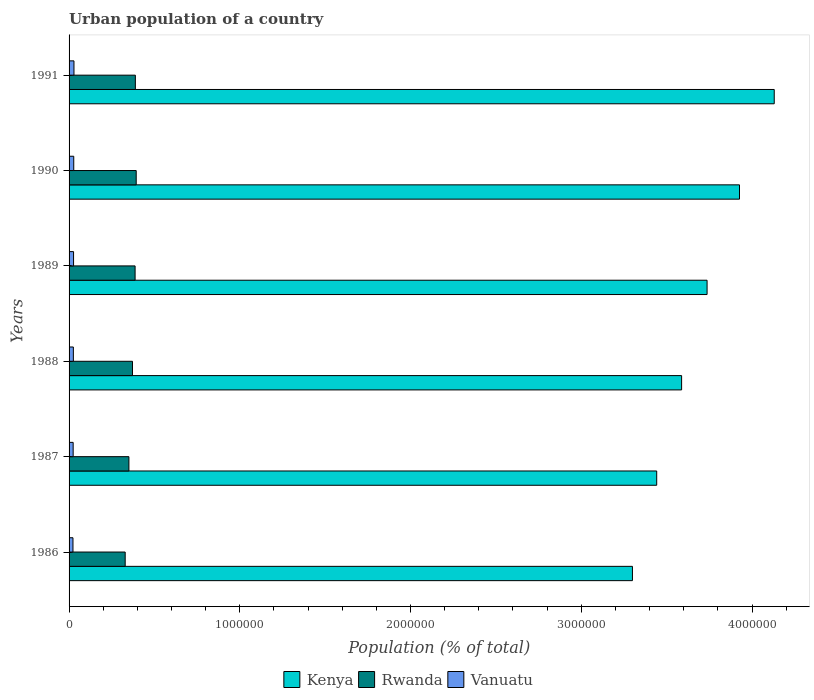How many different coloured bars are there?
Give a very brief answer. 3. How many groups of bars are there?
Offer a very short reply. 6. Are the number of bars per tick equal to the number of legend labels?
Give a very brief answer. Yes. How many bars are there on the 1st tick from the bottom?
Ensure brevity in your answer.  3. What is the urban population in Kenya in 1988?
Your response must be concise. 3.59e+06. Across all years, what is the maximum urban population in Rwanda?
Your response must be concise. 3.93e+05. Across all years, what is the minimum urban population in Kenya?
Offer a terse response. 3.30e+06. In which year was the urban population in Rwanda maximum?
Your answer should be compact. 1990. What is the total urban population in Kenya in the graph?
Keep it short and to the point. 2.21e+07. What is the difference between the urban population in Vanuatu in 1988 and that in 1991?
Your answer should be very brief. -3543. What is the difference between the urban population in Kenya in 1991 and the urban population in Vanuatu in 1988?
Ensure brevity in your answer.  4.11e+06. What is the average urban population in Vanuatu per year?
Provide a succinct answer. 2.57e+04. In the year 1986, what is the difference between the urban population in Rwanda and urban population in Vanuatu?
Give a very brief answer. 3.06e+05. What is the ratio of the urban population in Kenya in 1986 to that in 1991?
Provide a short and direct response. 0.8. Is the urban population in Kenya in 1990 less than that in 1991?
Your answer should be compact. Yes. What is the difference between the highest and the second highest urban population in Kenya?
Your answer should be very brief. 2.03e+05. What is the difference between the highest and the lowest urban population in Kenya?
Offer a terse response. 8.31e+05. What does the 3rd bar from the top in 1987 represents?
Ensure brevity in your answer.  Kenya. What does the 3rd bar from the bottom in 1990 represents?
Provide a succinct answer. Vanuatu. Is it the case that in every year, the sum of the urban population in Kenya and urban population in Vanuatu is greater than the urban population in Rwanda?
Make the answer very short. Yes. How many bars are there?
Your response must be concise. 18. Are all the bars in the graph horizontal?
Keep it short and to the point. Yes. How many years are there in the graph?
Offer a very short reply. 6. Does the graph contain any zero values?
Give a very brief answer. No. Does the graph contain grids?
Ensure brevity in your answer.  No. Where does the legend appear in the graph?
Your response must be concise. Bottom center. How are the legend labels stacked?
Your response must be concise. Horizontal. What is the title of the graph?
Offer a very short reply. Urban population of a country. Does "Chad" appear as one of the legend labels in the graph?
Offer a very short reply. No. What is the label or title of the X-axis?
Ensure brevity in your answer.  Population (% of total). What is the Population (% of total) of Kenya in 1986?
Your response must be concise. 3.30e+06. What is the Population (% of total) in Rwanda in 1986?
Your answer should be very brief. 3.29e+05. What is the Population (% of total) in Vanuatu in 1986?
Keep it short and to the point. 2.28e+04. What is the Population (% of total) in Kenya in 1987?
Your answer should be compact. 3.44e+06. What is the Population (% of total) of Rwanda in 1987?
Offer a very short reply. 3.50e+05. What is the Population (% of total) in Vanuatu in 1987?
Ensure brevity in your answer.  2.39e+04. What is the Population (% of total) of Kenya in 1988?
Provide a short and direct response. 3.59e+06. What is the Population (% of total) in Rwanda in 1988?
Give a very brief answer. 3.71e+05. What is the Population (% of total) in Vanuatu in 1988?
Offer a very short reply. 2.51e+04. What is the Population (% of total) in Kenya in 1989?
Ensure brevity in your answer.  3.74e+06. What is the Population (% of total) of Rwanda in 1989?
Provide a short and direct response. 3.87e+05. What is the Population (% of total) of Vanuatu in 1989?
Ensure brevity in your answer.  2.63e+04. What is the Population (% of total) in Kenya in 1990?
Offer a very short reply. 3.93e+06. What is the Population (% of total) of Rwanda in 1990?
Provide a short and direct response. 3.93e+05. What is the Population (% of total) of Vanuatu in 1990?
Ensure brevity in your answer.  2.74e+04. What is the Population (% of total) in Kenya in 1991?
Your response must be concise. 4.13e+06. What is the Population (% of total) in Rwanda in 1991?
Provide a succinct answer. 3.88e+05. What is the Population (% of total) of Vanuatu in 1991?
Provide a succinct answer. 2.86e+04. Across all years, what is the maximum Population (% of total) in Kenya?
Provide a succinct answer. 4.13e+06. Across all years, what is the maximum Population (% of total) in Rwanda?
Offer a terse response. 3.93e+05. Across all years, what is the maximum Population (% of total) of Vanuatu?
Offer a very short reply. 2.86e+04. Across all years, what is the minimum Population (% of total) of Kenya?
Your response must be concise. 3.30e+06. Across all years, what is the minimum Population (% of total) in Rwanda?
Give a very brief answer. 3.29e+05. Across all years, what is the minimum Population (% of total) in Vanuatu?
Ensure brevity in your answer.  2.28e+04. What is the total Population (% of total) of Kenya in the graph?
Keep it short and to the point. 2.21e+07. What is the total Population (% of total) in Rwanda in the graph?
Offer a very short reply. 2.22e+06. What is the total Population (% of total) in Vanuatu in the graph?
Provide a short and direct response. 1.54e+05. What is the difference between the Population (% of total) of Kenya in 1986 and that in 1987?
Your answer should be very brief. -1.42e+05. What is the difference between the Population (% of total) of Rwanda in 1986 and that in 1987?
Offer a terse response. -2.18e+04. What is the difference between the Population (% of total) in Vanuatu in 1986 and that in 1987?
Offer a very short reply. -1115. What is the difference between the Population (% of total) in Kenya in 1986 and that in 1988?
Make the answer very short. -2.88e+05. What is the difference between the Population (% of total) of Rwanda in 1986 and that in 1988?
Your answer should be very brief. -4.28e+04. What is the difference between the Population (% of total) in Vanuatu in 1986 and that in 1988?
Provide a succinct answer. -2295. What is the difference between the Population (% of total) in Kenya in 1986 and that in 1989?
Provide a short and direct response. -4.37e+05. What is the difference between the Population (% of total) in Rwanda in 1986 and that in 1989?
Your answer should be very brief. -5.80e+04. What is the difference between the Population (% of total) in Vanuatu in 1986 and that in 1989?
Provide a succinct answer. -3528. What is the difference between the Population (% of total) of Kenya in 1986 and that in 1990?
Offer a terse response. -6.27e+05. What is the difference between the Population (% of total) in Rwanda in 1986 and that in 1990?
Offer a very short reply. -6.45e+04. What is the difference between the Population (% of total) in Vanuatu in 1986 and that in 1990?
Offer a very short reply. -4635. What is the difference between the Population (% of total) in Kenya in 1986 and that in 1991?
Provide a short and direct response. -8.31e+05. What is the difference between the Population (% of total) of Rwanda in 1986 and that in 1991?
Provide a succinct answer. -5.96e+04. What is the difference between the Population (% of total) in Vanuatu in 1986 and that in 1991?
Offer a very short reply. -5838. What is the difference between the Population (% of total) in Kenya in 1987 and that in 1988?
Your answer should be compact. -1.46e+05. What is the difference between the Population (% of total) of Rwanda in 1987 and that in 1988?
Make the answer very short. -2.10e+04. What is the difference between the Population (% of total) of Vanuatu in 1987 and that in 1988?
Your response must be concise. -1180. What is the difference between the Population (% of total) of Kenya in 1987 and that in 1989?
Make the answer very short. -2.95e+05. What is the difference between the Population (% of total) of Rwanda in 1987 and that in 1989?
Ensure brevity in your answer.  -3.62e+04. What is the difference between the Population (% of total) of Vanuatu in 1987 and that in 1989?
Your answer should be compact. -2413. What is the difference between the Population (% of total) of Kenya in 1987 and that in 1990?
Offer a terse response. -4.85e+05. What is the difference between the Population (% of total) of Rwanda in 1987 and that in 1990?
Give a very brief answer. -4.27e+04. What is the difference between the Population (% of total) of Vanuatu in 1987 and that in 1990?
Make the answer very short. -3520. What is the difference between the Population (% of total) of Kenya in 1987 and that in 1991?
Make the answer very short. -6.88e+05. What is the difference between the Population (% of total) of Rwanda in 1987 and that in 1991?
Your answer should be very brief. -3.78e+04. What is the difference between the Population (% of total) of Vanuatu in 1987 and that in 1991?
Your answer should be compact. -4723. What is the difference between the Population (% of total) of Kenya in 1988 and that in 1989?
Give a very brief answer. -1.49e+05. What is the difference between the Population (% of total) of Rwanda in 1988 and that in 1989?
Offer a terse response. -1.53e+04. What is the difference between the Population (% of total) of Vanuatu in 1988 and that in 1989?
Give a very brief answer. -1233. What is the difference between the Population (% of total) in Kenya in 1988 and that in 1990?
Give a very brief answer. -3.39e+05. What is the difference between the Population (% of total) of Rwanda in 1988 and that in 1990?
Ensure brevity in your answer.  -2.18e+04. What is the difference between the Population (% of total) in Vanuatu in 1988 and that in 1990?
Your answer should be very brief. -2340. What is the difference between the Population (% of total) in Kenya in 1988 and that in 1991?
Your response must be concise. -5.43e+05. What is the difference between the Population (% of total) of Rwanda in 1988 and that in 1991?
Provide a short and direct response. -1.69e+04. What is the difference between the Population (% of total) in Vanuatu in 1988 and that in 1991?
Provide a succinct answer. -3543. What is the difference between the Population (% of total) of Kenya in 1989 and that in 1990?
Provide a short and direct response. -1.90e+05. What is the difference between the Population (% of total) of Rwanda in 1989 and that in 1990?
Make the answer very short. -6475. What is the difference between the Population (% of total) of Vanuatu in 1989 and that in 1990?
Offer a terse response. -1107. What is the difference between the Population (% of total) in Kenya in 1989 and that in 1991?
Provide a short and direct response. -3.93e+05. What is the difference between the Population (% of total) in Rwanda in 1989 and that in 1991?
Your response must be concise. -1577. What is the difference between the Population (% of total) of Vanuatu in 1989 and that in 1991?
Your response must be concise. -2310. What is the difference between the Population (% of total) of Kenya in 1990 and that in 1991?
Provide a succinct answer. -2.03e+05. What is the difference between the Population (% of total) of Rwanda in 1990 and that in 1991?
Make the answer very short. 4898. What is the difference between the Population (% of total) in Vanuatu in 1990 and that in 1991?
Provide a succinct answer. -1203. What is the difference between the Population (% of total) of Kenya in 1986 and the Population (% of total) of Rwanda in 1987?
Your answer should be compact. 2.95e+06. What is the difference between the Population (% of total) of Kenya in 1986 and the Population (% of total) of Vanuatu in 1987?
Ensure brevity in your answer.  3.28e+06. What is the difference between the Population (% of total) of Rwanda in 1986 and the Population (% of total) of Vanuatu in 1987?
Your response must be concise. 3.05e+05. What is the difference between the Population (% of total) in Kenya in 1986 and the Population (% of total) in Rwanda in 1988?
Your answer should be compact. 2.93e+06. What is the difference between the Population (% of total) in Kenya in 1986 and the Population (% of total) in Vanuatu in 1988?
Your answer should be very brief. 3.27e+06. What is the difference between the Population (% of total) in Rwanda in 1986 and the Population (% of total) in Vanuatu in 1988?
Provide a succinct answer. 3.04e+05. What is the difference between the Population (% of total) of Kenya in 1986 and the Population (% of total) of Rwanda in 1989?
Offer a very short reply. 2.91e+06. What is the difference between the Population (% of total) in Kenya in 1986 and the Population (% of total) in Vanuatu in 1989?
Offer a very short reply. 3.27e+06. What is the difference between the Population (% of total) of Rwanda in 1986 and the Population (% of total) of Vanuatu in 1989?
Ensure brevity in your answer.  3.02e+05. What is the difference between the Population (% of total) of Kenya in 1986 and the Population (% of total) of Rwanda in 1990?
Your response must be concise. 2.91e+06. What is the difference between the Population (% of total) in Kenya in 1986 and the Population (% of total) in Vanuatu in 1990?
Offer a very short reply. 3.27e+06. What is the difference between the Population (% of total) of Rwanda in 1986 and the Population (% of total) of Vanuatu in 1990?
Keep it short and to the point. 3.01e+05. What is the difference between the Population (% of total) of Kenya in 1986 and the Population (% of total) of Rwanda in 1991?
Your response must be concise. 2.91e+06. What is the difference between the Population (% of total) of Kenya in 1986 and the Population (% of total) of Vanuatu in 1991?
Offer a terse response. 3.27e+06. What is the difference between the Population (% of total) in Rwanda in 1986 and the Population (% of total) in Vanuatu in 1991?
Provide a succinct answer. 3.00e+05. What is the difference between the Population (% of total) of Kenya in 1987 and the Population (% of total) of Rwanda in 1988?
Provide a short and direct response. 3.07e+06. What is the difference between the Population (% of total) of Kenya in 1987 and the Population (% of total) of Vanuatu in 1988?
Offer a terse response. 3.42e+06. What is the difference between the Population (% of total) of Rwanda in 1987 and the Population (% of total) of Vanuatu in 1988?
Make the answer very short. 3.25e+05. What is the difference between the Population (% of total) in Kenya in 1987 and the Population (% of total) in Rwanda in 1989?
Offer a very short reply. 3.06e+06. What is the difference between the Population (% of total) of Kenya in 1987 and the Population (% of total) of Vanuatu in 1989?
Ensure brevity in your answer.  3.42e+06. What is the difference between the Population (% of total) of Rwanda in 1987 and the Population (% of total) of Vanuatu in 1989?
Offer a terse response. 3.24e+05. What is the difference between the Population (% of total) in Kenya in 1987 and the Population (% of total) in Rwanda in 1990?
Provide a succinct answer. 3.05e+06. What is the difference between the Population (% of total) in Kenya in 1987 and the Population (% of total) in Vanuatu in 1990?
Your answer should be very brief. 3.41e+06. What is the difference between the Population (% of total) in Rwanda in 1987 and the Population (% of total) in Vanuatu in 1990?
Provide a short and direct response. 3.23e+05. What is the difference between the Population (% of total) in Kenya in 1987 and the Population (% of total) in Rwanda in 1991?
Make the answer very short. 3.05e+06. What is the difference between the Population (% of total) of Kenya in 1987 and the Population (% of total) of Vanuatu in 1991?
Give a very brief answer. 3.41e+06. What is the difference between the Population (% of total) of Rwanda in 1987 and the Population (% of total) of Vanuatu in 1991?
Make the answer very short. 3.22e+05. What is the difference between the Population (% of total) of Kenya in 1988 and the Population (% of total) of Rwanda in 1989?
Keep it short and to the point. 3.20e+06. What is the difference between the Population (% of total) in Kenya in 1988 and the Population (% of total) in Vanuatu in 1989?
Your answer should be very brief. 3.56e+06. What is the difference between the Population (% of total) in Rwanda in 1988 and the Population (% of total) in Vanuatu in 1989?
Your response must be concise. 3.45e+05. What is the difference between the Population (% of total) in Kenya in 1988 and the Population (% of total) in Rwanda in 1990?
Provide a short and direct response. 3.19e+06. What is the difference between the Population (% of total) of Kenya in 1988 and the Population (% of total) of Vanuatu in 1990?
Keep it short and to the point. 3.56e+06. What is the difference between the Population (% of total) in Rwanda in 1988 and the Population (% of total) in Vanuatu in 1990?
Offer a very short reply. 3.44e+05. What is the difference between the Population (% of total) of Kenya in 1988 and the Population (% of total) of Rwanda in 1991?
Provide a succinct answer. 3.20e+06. What is the difference between the Population (% of total) of Kenya in 1988 and the Population (% of total) of Vanuatu in 1991?
Keep it short and to the point. 3.56e+06. What is the difference between the Population (% of total) of Rwanda in 1988 and the Population (% of total) of Vanuatu in 1991?
Make the answer very short. 3.43e+05. What is the difference between the Population (% of total) in Kenya in 1989 and the Population (% of total) in Rwanda in 1990?
Offer a terse response. 3.34e+06. What is the difference between the Population (% of total) in Kenya in 1989 and the Population (% of total) in Vanuatu in 1990?
Your answer should be very brief. 3.71e+06. What is the difference between the Population (% of total) of Rwanda in 1989 and the Population (% of total) of Vanuatu in 1990?
Make the answer very short. 3.59e+05. What is the difference between the Population (% of total) of Kenya in 1989 and the Population (% of total) of Rwanda in 1991?
Give a very brief answer. 3.35e+06. What is the difference between the Population (% of total) of Kenya in 1989 and the Population (% of total) of Vanuatu in 1991?
Offer a very short reply. 3.71e+06. What is the difference between the Population (% of total) in Rwanda in 1989 and the Population (% of total) in Vanuatu in 1991?
Give a very brief answer. 3.58e+05. What is the difference between the Population (% of total) of Kenya in 1990 and the Population (% of total) of Rwanda in 1991?
Offer a terse response. 3.54e+06. What is the difference between the Population (% of total) of Kenya in 1990 and the Population (% of total) of Vanuatu in 1991?
Offer a terse response. 3.90e+06. What is the difference between the Population (% of total) of Rwanda in 1990 and the Population (% of total) of Vanuatu in 1991?
Your answer should be compact. 3.65e+05. What is the average Population (% of total) in Kenya per year?
Give a very brief answer. 3.69e+06. What is the average Population (% of total) in Rwanda per year?
Make the answer very short. 3.70e+05. What is the average Population (% of total) of Vanuatu per year?
Your answer should be compact. 2.57e+04. In the year 1986, what is the difference between the Population (% of total) of Kenya and Population (% of total) of Rwanda?
Your answer should be very brief. 2.97e+06. In the year 1986, what is the difference between the Population (% of total) in Kenya and Population (% of total) in Vanuatu?
Your answer should be compact. 3.28e+06. In the year 1986, what is the difference between the Population (% of total) in Rwanda and Population (% of total) in Vanuatu?
Provide a succinct answer. 3.06e+05. In the year 1987, what is the difference between the Population (% of total) of Kenya and Population (% of total) of Rwanda?
Your answer should be compact. 3.09e+06. In the year 1987, what is the difference between the Population (% of total) in Kenya and Population (% of total) in Vanuatu?
Offer a terse response. 3.42e+06. In the year 1987, what is the difference between the Population (% of total) of Rwanda and Population (% of total) of Vanuatu?
Provide a succinct answer. 3.27e+05. In the year 1988, what is the difference between the Population (% of total) of Kenya and Population (% of total) of Rwanda?
Your answer should be very brief. 3.22e+06. In the year 1988, what is the difference between the Population (% of total) of Kenya and Population (% of total) of Vanuatu?
Provide a short and direct response. 3.56e+06. In the year 1988, what is the difference between the Population (% of total) in Rwanda and Population (% of total) in Vanuatu?
Your response must be concise. 3.46e+05. In the year 1989, what is the difference between the Population (% of total) in Kenya and Population (% of total) in Rwanda?
Keep it short and to the point. 3.35e+06. In the year 1989, what is the difference between the Population (% of total) in Kenya and Population (% of total) in Vanuatu?
Make the answer very short. 3.71e+06. In the year 1989, what is the difference between the Population (% of total) of Rwanda and Population (% of total) of Vanuatu?
Provide a short and direct response. 3.60e+05. In the year 1990, what is the difference between the Population (% of total) of Kenya and Population (% of total) of Rwanda?
Make the answer very short. 3.53e+06. In the year 1990, what is the difference between the Population (% of total) of Kenya and Population (% of total) of Vanuatu?
Your answer should be compact. 3.90e+06. In the year 1990, what is the difference between the Population (% of total) in Rwanda and Population (% of total) in Vanuatu?
Offer a terse response. 3.66e+05. In the year 1991, what is the difference between the Population (% of total) in Kenya and Population (% of total) in Rwanda?
Provide a succinct answer. 3.74e+06. In the year 1991, what is the difference between the Population (% of total) in Kenya and Population (% of total) in Vanuatu?
Your answer should be very brief. 4.10e+06. In the year 1991, what is the difference between the Population (% of total) of Rwanda and Population (% of total) of Vanuatu?
Provide a short and direct response. 3.60e+05. What is the ratio of the Population (% of total) of Kenya in 1986 to that in 1987?
Your answer should be very brief. 0.96. What is the ratio of the Population (% of total) of Rwanda in 1986 to that in 1987?
Keep it short and to the point. 0.94. What is the ratio of the Population (% of total) in Vanuatu in 1986 to that in 1987?
Your answer should be compact. 0.95. What is the ratio of the Population (% of total) of Kenya in 1986 to that in 1988?
Provide a short and direct response. 0.92. What is the ratio of the Population (% of total) of Rwanda in 1986 to that in 1988?
Give a very brief answer. 0.88. What is the ratio of the Population (% of total) in Vanuatu in 1986 to that in 1988?
Provide a succinct answer. 0.91. What is the ratio of the Population (% of total) in Kenya in 1986 to that in 1989?
Offer a terse response. 0.88. What is the ratio of the Population (% of total) of Rwanda in 1986 to that in 1989?
Your answer should be very brief. 0.85. What is the ratio of the Population (% of total) in Vanuatu in 1986 to that in 1989?
Make the answer very short. 0.87. What is the ratio of the Population (% of total) in Kenya in 1986 to that in 1990?
Your response must be concise. 0.84. What is the ratio of the Population (% of total) of Rwanda in 1986 to that in 1990?
Provide a short and direct response. 0.84. What is the ratio of the Population (% of total) of Vanuatu in 1986 to that in 1990?
Your response must be concise. 0.83. What is the ratio of the Population (% of total) of Kenya in 1986 to that in 1991?
Keep it short and to the point. 0.8. What is the ratio of the Population (% of total) of Rwanda in 1986 to that in 1991?
Make the answer very short. 0.85. What is the ratio of the Population (% of total) of Vanuatu in 1986 to that in 1991?
Your response must be concise. 0.8. What is the ratio of the Population (% of total) in Kenya in 1987 to that in 1988?
Offer a very short reply. 0.96. What is the ratio of the Population (% of total) in Rwanda in 1987 to that in 1988?
Ensure brevity in your answer.  0.94. What is the ratio of the Population (% of total) of Vanuatu in 1987 to that in 1988?
Provide a succinct answer. 0.95. What is the ratio of the Population (% of total) in Kenya in 1987 to that in 1989?
Give a very brief answer. 0.92. What is the ratio of the Population (% of total) in Rwanda in 1987 to that in 1989?
Provide a succinct answer. 0.91. What is the ratio of the Population (% of total) of Vanuatu in 1987 to that in 1989?
Your response must be concise. 0.91. What is the ratio of the Population (% of total) of Kenya in 1987 to that in 1990?
Make the answer very short. 0.88. What is the ratio of the Population (% of total) in Rwanda in 1987 to that in 1990?
Your answer should be very brief. 0.89. What is the ratio of the Population (% of total) of Vanuatu in 1987 to that in 1990?
Offer a terse response. 0.87. What is the ratio of the Population (% of total) in Kenya in 1987 to that in 1991?
Your answer should be compact. 0.83. What is the ratio of the Population (% of total) in Rwanda in 1987 to that in 1991?
Make the answer very short. 0.9. What is the ratio of the Population (% of total) in Vanuatu in 1987 to that in 1991?
Your answer should be very brief. 0.84. What is the ratio of the Population (% of total) in Kenya in 1988 to that in 1989?
Give a very brief answer. 0.96. What is the ratio of the Population (% of total) of Rwanda in 1988 to that in 1989?
Your answer should be compact. 0.96. What is the ratio of the Population (% of total) in Vanuatu in 1988 to that in 1989?
Your response must be concise. 0.95. What is the ratio of the Population (% of total) of Kenya in 1988 to that in 1990?
Offer a very short reply. 0.91. What is the ratio of the Population (% of total) of Rwanda in 1988 to that in 1990?
Your answer should be compact. 0.94. What is the ratio of the Population (% of total) of Vanuatu in 1988 to that in 1990?
Your response must be concise. 0.91. What is the ratio of the Population (% of total) in Kenya in 1988 to that in 1991?
Keep it short and to the point. 0.87. What is the ratio of the Population (% of total) of Rwanda in 1988 to that in 1991?
Keep it short and to the point. 0.96. What is the ratio of the Population (% of total) of Vanuatu in 1988 to that in 1991?
Provide a short and direct response. 0.88. What is the ratio of the Population (% of total) of Kenya in 1989 to that in 1990?
Your answer should be compact. 0.95. What is the ratio of the Population (% of total) of Rwanda in 1989 to that in 1990?
Ensure brevity in your answer.  0.98. What is the ratio of the Population (% of total) of Vanuatu in 1989 to that in 1990?
Ensure brevity in your answer.  0.96. What is the ratio of the Population (% of total) of Kenya in 1989 to that in 1991?
Keep it short and to the point. 0.9. What is the ratio of the Population (% of total) in Rwanda in 1989 to that in 1991?
Offer a terse response. 1. What is the ratio of the Population (% of total) in Vanuatu in 1989 to that in 1991?
Offer a terse response. 0.92. What is the ratio of the Population (% of total) in Kenya in 1990 to that in 1991?
Ensure brevity in your answer.  0.95. What is the ratio of the Population (% of total) in Rwanda in 1990 to that in 1991?
Your answer should be compact. 1.01. What is the ratio of the Population (% of total) in Vanuatu in 1990 to that in 1991?
Provide a short and direct response. 0.96. What is the difference between the highest and the second highest Population (% of total) in Kenya?
Offer a very short reply. 2.03e+05. What is the difference between the highest and the second highest Population (% of total) of Rwanda?
Make the answer very short. 4898. What is the difference between the highest and the second highest Population (% of total) in Vanuatu?
Offer a terse response. 1203. What is the difference between the highest and the lowest Population (% of total) in Kenya?
Ensure brevity in your answer.  8.31e+05. What is the difference between the highest and the lowest Population (% of total) of Rwanda?
Offer a very short reply. 6.45e+04. What is the difference between the highest and the lowest Population (% of total) in Vanuatu?
Your answer should be very brief. 5838. 